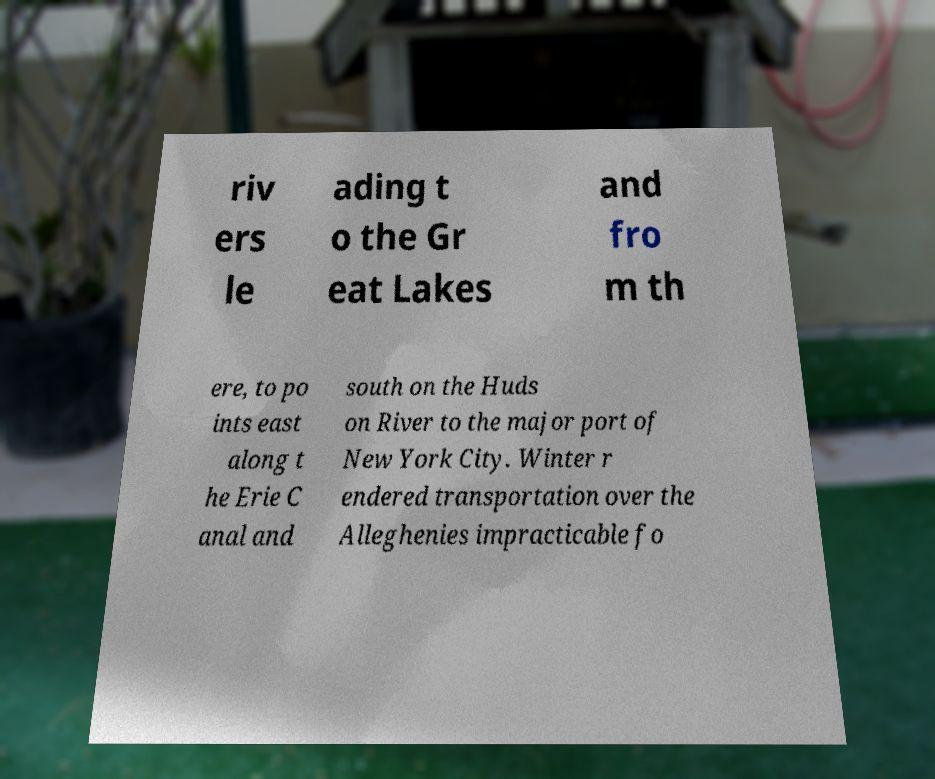Could you assist in decoding the text presented in this image and type it out clearly? riv ers le ading t o the Gr eat Lakes and fro m th ere, to po ints east along t he Erie C anal and south on the Huds on River to the major port of New York City. Winter r endered transportation over the Alleghenies impracticable fo 